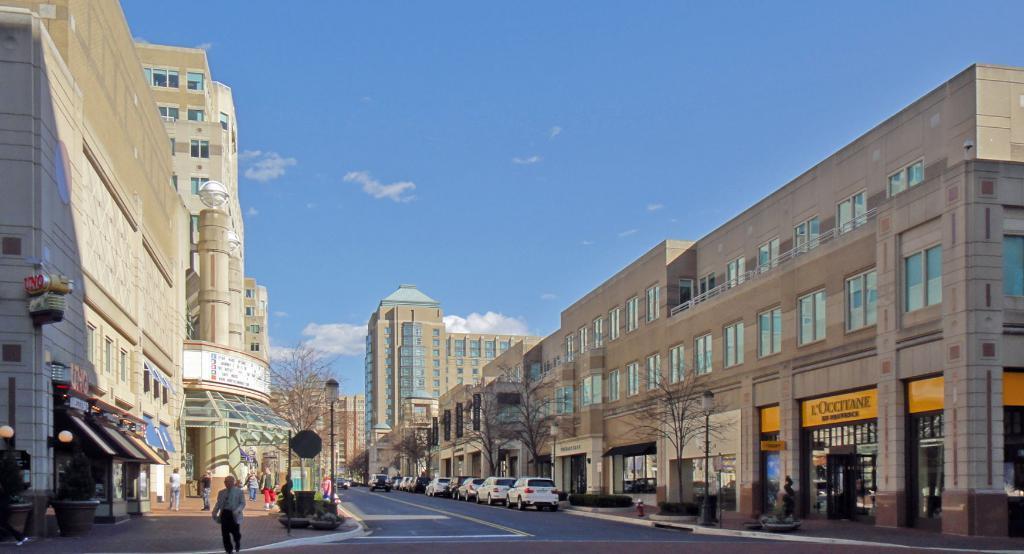Please provide a concise description of this image. In the bottom left corner of the image few people are walking. In the middle of the image we can see some vehicles on the road. Behind the vehicles we can see some trees, poles, buildings and plants. At the top of the image we can see some clouds in the sky. 